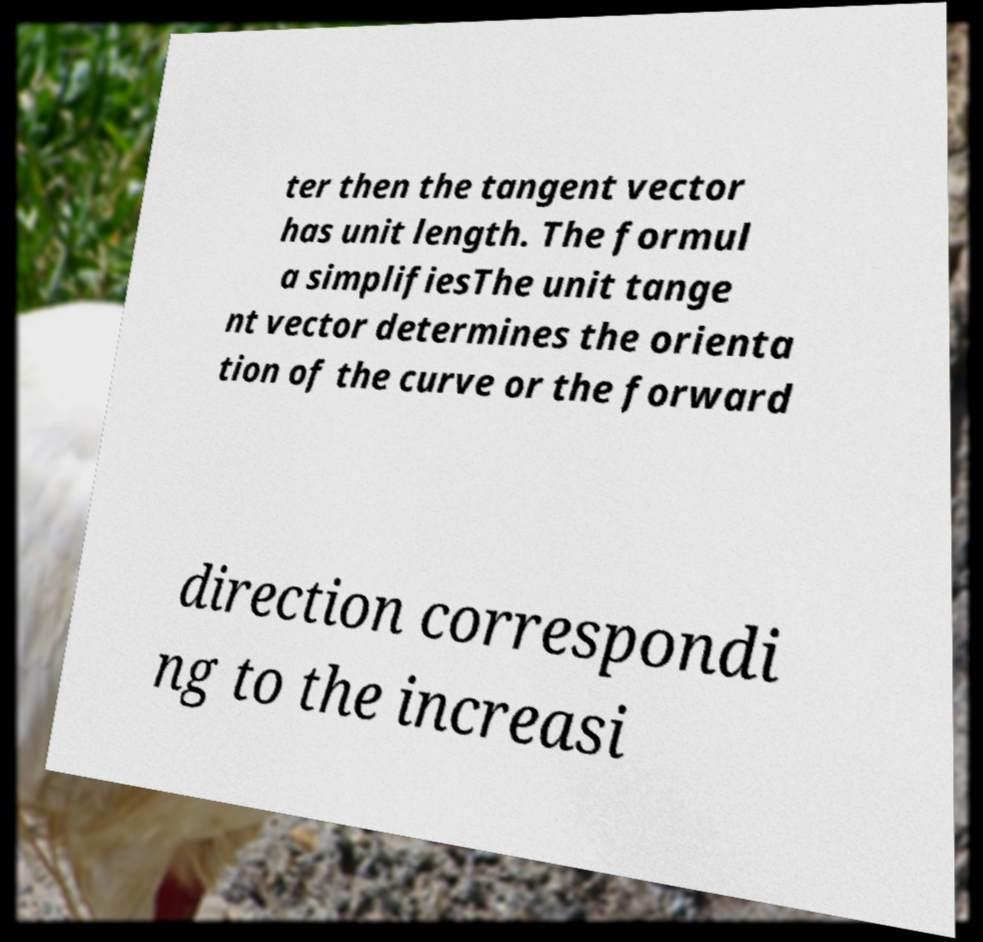Please read and relay the text visible in this image. What does it say? ter then the tangent vector has unit length. The formul a simplifiesThe unit tange nt vector determines the orienta tion of the curve or the forward direction correspondi ng to the increasi 